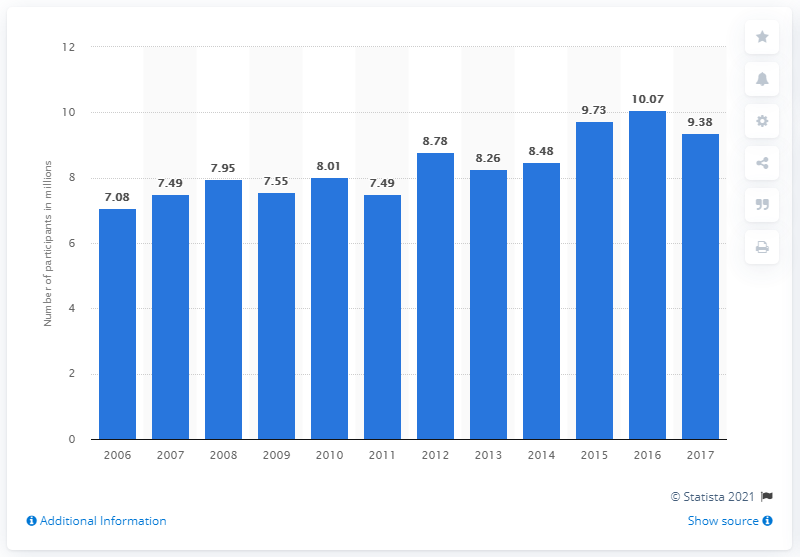Highlight a few significant elements in this photo. In 2017, there were 9.38 people who participated in shooting sports. 